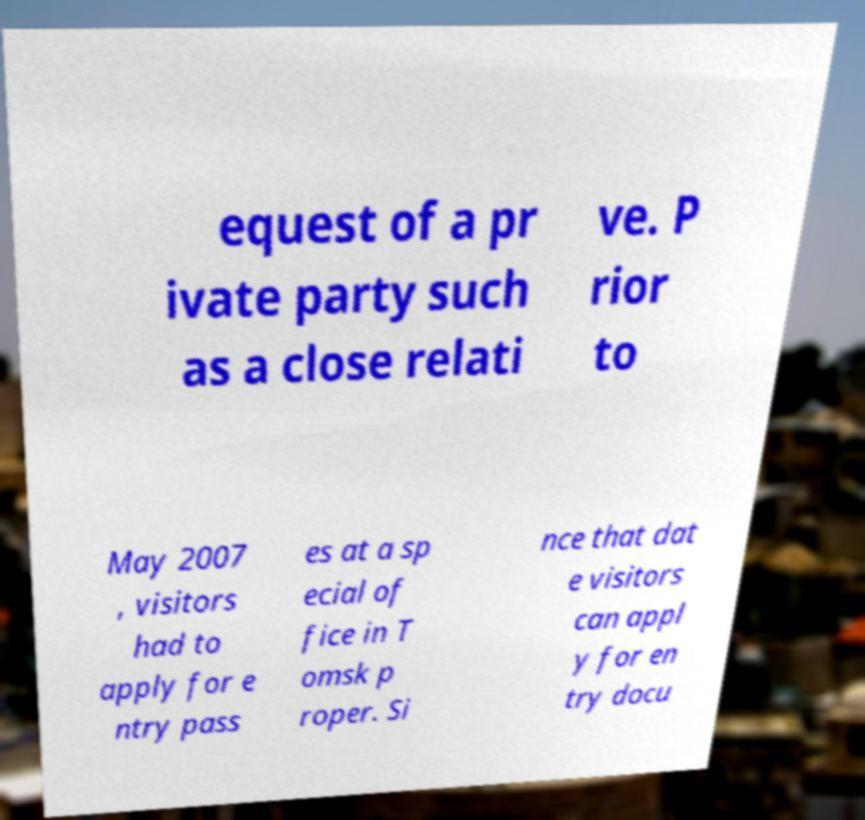Could you assist in decoding the text presented in this image and type it out clearly? equest of a pr ivate party such as a close relati ve. P rior to May 2007 , visitors had to apply for e ntry pass es at a sp ecial of fice in T omsk p roper. Si nce that dat e visitors can appl y for en try docu 